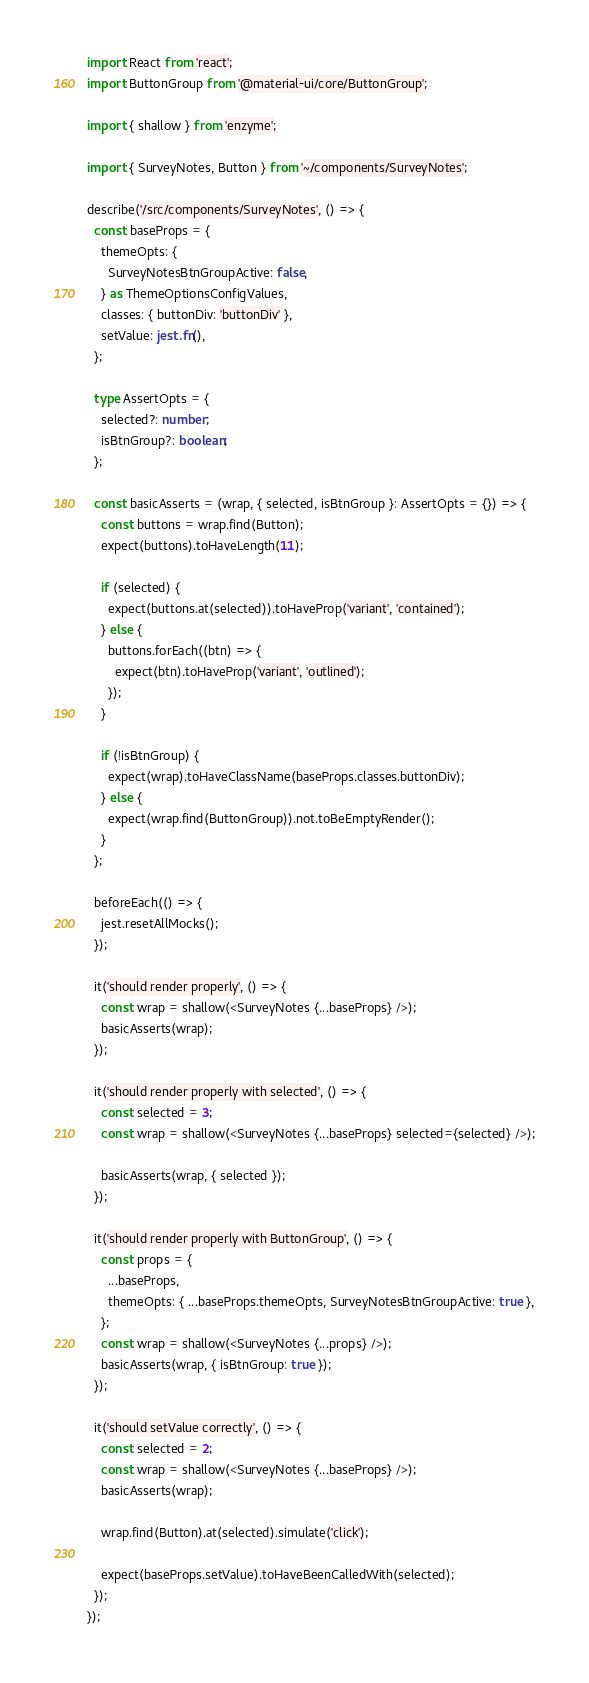Convert code to text. <code><loc_0><loc_0><loc_500><loc_500><_TypeScript_>import React from 'react';
import ButtonGroup from '@material-ui/core/ButtonGroup';

import { shallow } from 'enzyme';

import { SurveyNotes, Button } from '~/components/SurveyNotes';

describe('/src/components/SurveyNotes', () => {
  const baseProps = {
    themeOpts: {
      SurveyNotesBtnGroupActive: false,
    } as ThemeOptionsConfigValues,
    classes: { buttonDiv: 'buttonDiv' },
    setValue: jest.fn(),
  };

  type AssertOpts = {
    selected?: number;
    isBtnGroup?: boolean;
  };

  const basicAsserts = (wrap, { selected, isBtnGroup }: AssertOpts = {}) => {
    const buttons = wrap.find(Button);
    expect(buttons).toHaveLength(11);

    if (selected) {
      expect(buttons.at(selected)).toHaveProp('variant', 'contained');
    } else {
      buttons.forEach((btn) => {
        expect(btn).toHaveProp('variant', 'outlined');
      });
    }

    if (!isBtnGroup) {
      expect(wrap).toHaveClassName(baseProps.classes.buttonDiv);
    } else {
      expect(wrap.find(ButtonGroup)).not.toBeEmptyRender();
    }
  };

  beforeEach(() => {
    jest.resetAllMocks();
  });

  it('should render properly', () => {
    const wrap = shallow(<SurveyNotes {...baseProps} />);
    basicAsserts(wrap);
  });

  it('should render properly with selected', () => {
    const selected = 3;
    const wrap = shallow(<SurveyNotes {...baseProps} selected={selected} />);

    basicAsserts(wrap, { selected });
  });

  it('should render properly with ButtonGroup', () => {
    const props = {
      ...baseProps,
      themeOpts: { ...baseProps.themeOpts, SurveyNotesBtnGroupActive: true },
    };
    const wrap = shallow(<SurveyNotes {...props} />);
    basicAsserts(wrap, { isBtnGroup: true });
  });

  it('should setValue correctly', () => {
    const selected = 2;
    const wrap = shallow(<SurveyNotes {...baseProps} />);
    basicAsserts(wrap);

    wrap.find(Button).at(selected).simulate('click');

    expect(baseProps.setValue).toHaveBeenCalledWith(selected);
  });
});
</code> 